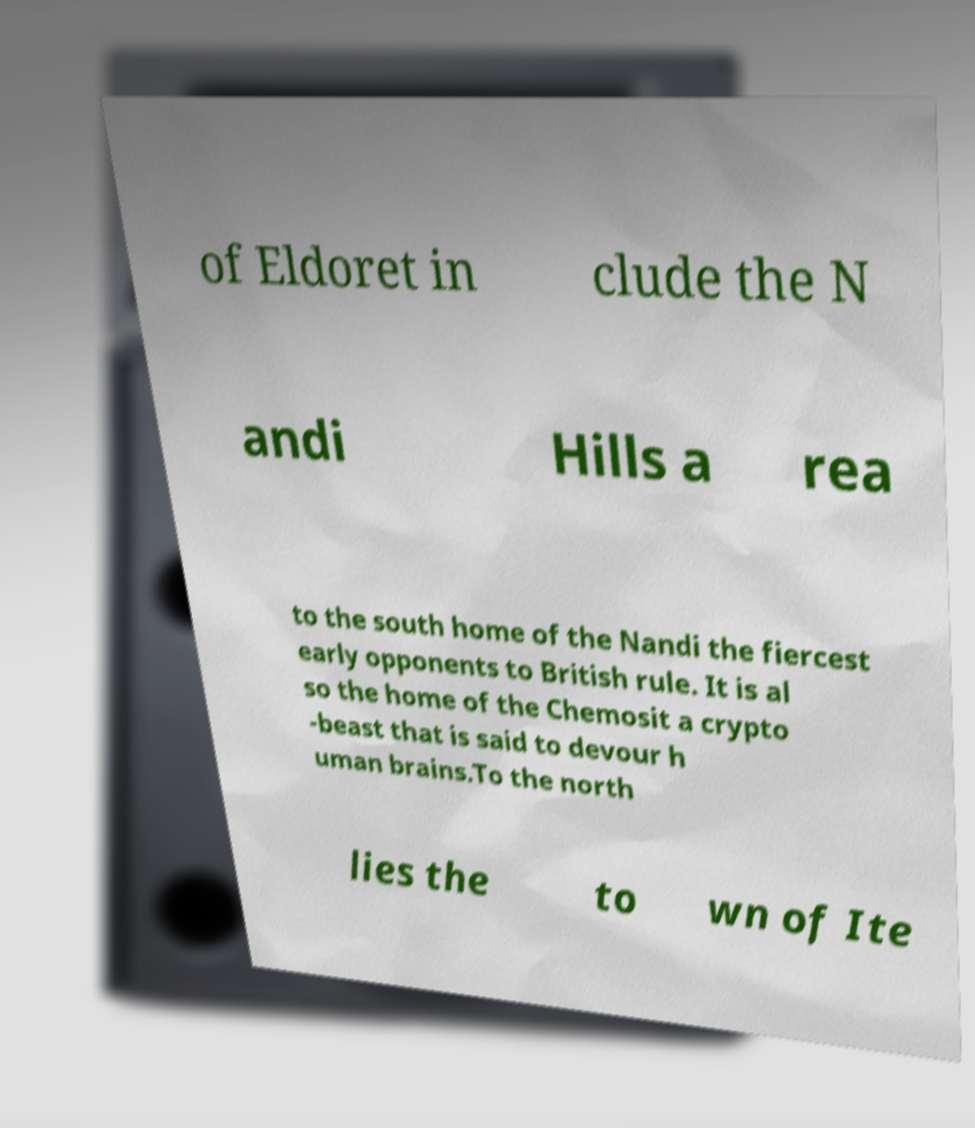Can you read and provide the text displayed in the image?This photo seems to have some interesting text. Can you extract and type it out for me? of Eldoret in clude the N andi Hills a rea to the south home of the Nandi the fiercest early opponents to British rule. It is al so the home of the Chemosit a crypto -beast that is said to devour h uman brains.To the north lies the to wn of Ite 